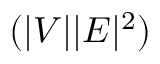<formula> <loc_0><loc_0><loc_500><loc_500>( | V | | E | ^ { 2 } )</formula> 